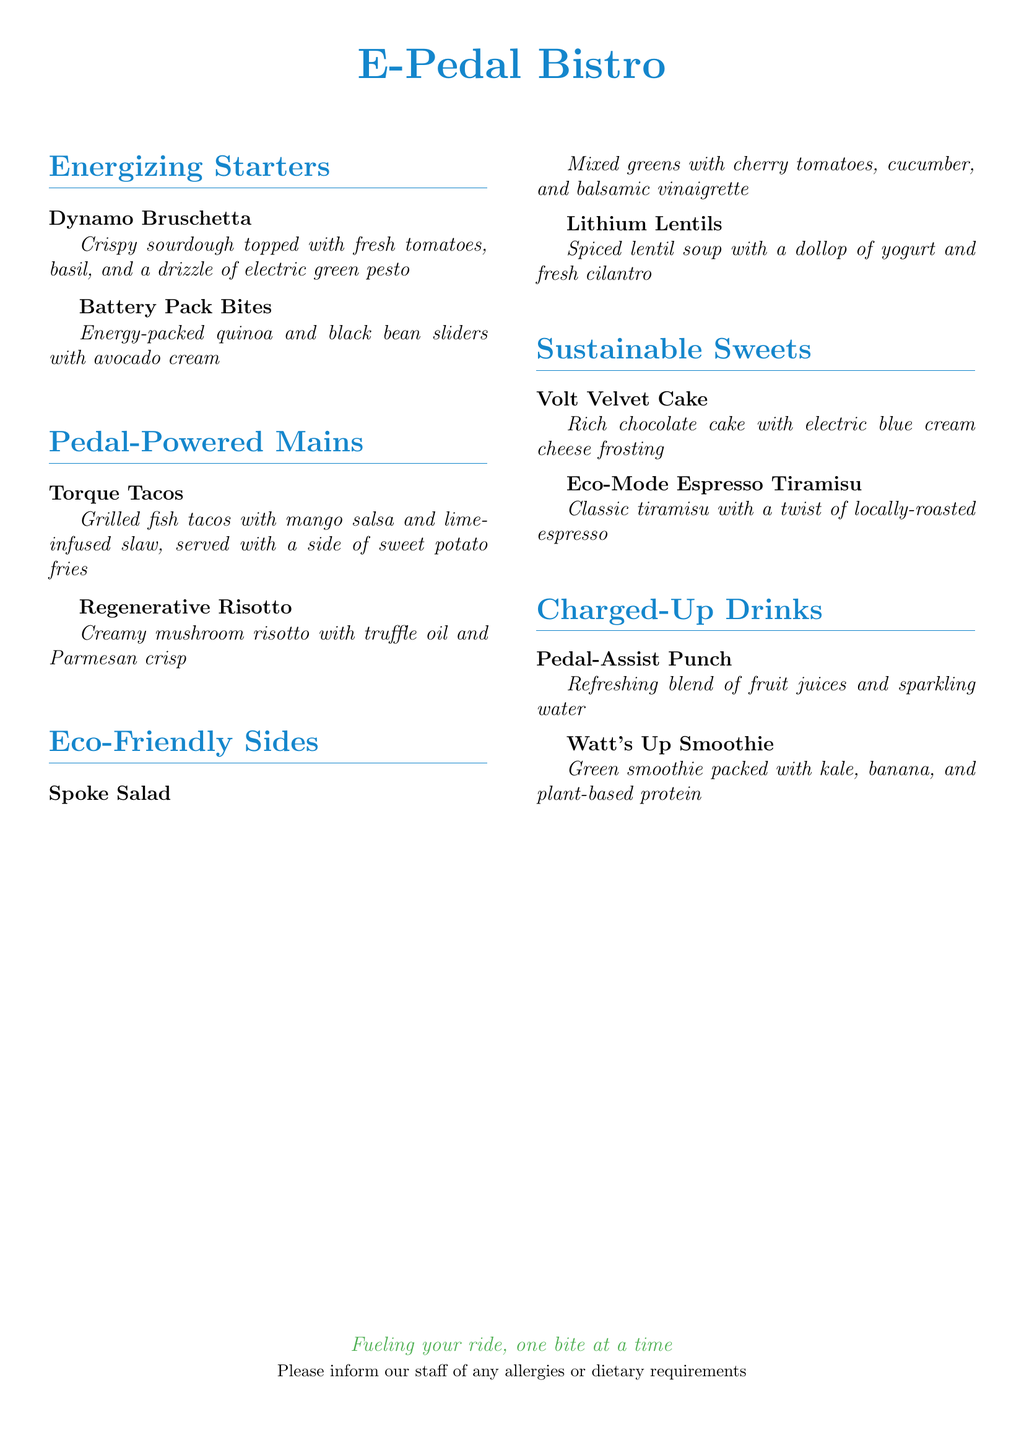What is the name of the restaurant? The name of the restaurant is presented prominently at the top of the menu.
Answer: E-Pedal Bistro What category does "Dynamo Bruschetta" belong to? The menu categorizes each dish under specific sections, with "Dynamo Bruschetta" listed under "Energizing Starters."
Answer: Energizing Starters What is the main ingredient of "Lithium Lentils"? The main content of "Lithium Lentils" is specified in the dish description.
Answer: Spiced lentil soup How many main dishes are listed on the menu? The menu features a count of dishes in each section, where the main dishes are found under "Pedal-Powered Mains."
Answer: 2 What drink contains protein? The description of "Watt's Up Smoothie" mentions its nutritional components.
Answer: Plant-based protein What type of cake is offered for dessert? The dessert section specifies the type of cake available.
Answer: Volt Velvet Cake Which side dish has a salad? The "Eco-Friendly Sides" section includes the dish that is a type of salad.
Answer: Spoke Salad What is the main flavor in "Eco-Mode Espresso Tiramisu"? The flavor component is highlighted in the dish description.
Answer: Locally-roasted espresso What is the color of the bistro's logo or title? The color of the title is mentioned at the beginning of the document.
Answer: Electric blue 